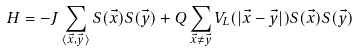<formula> <loc_0><loc_0><loc_500><loc_500>H = - J \sum _ { \langle \vec { x } , \vec { y } \rangle } S ( \vec { x } ) S ( \vec { y } ) + Q \sum _ { \vec { x } \neq \vec { y } } V _ { L } ( | \vec { x } - \vec { y } | ) S ( \vec { x } ) S ( \vec { y } )</formula> 